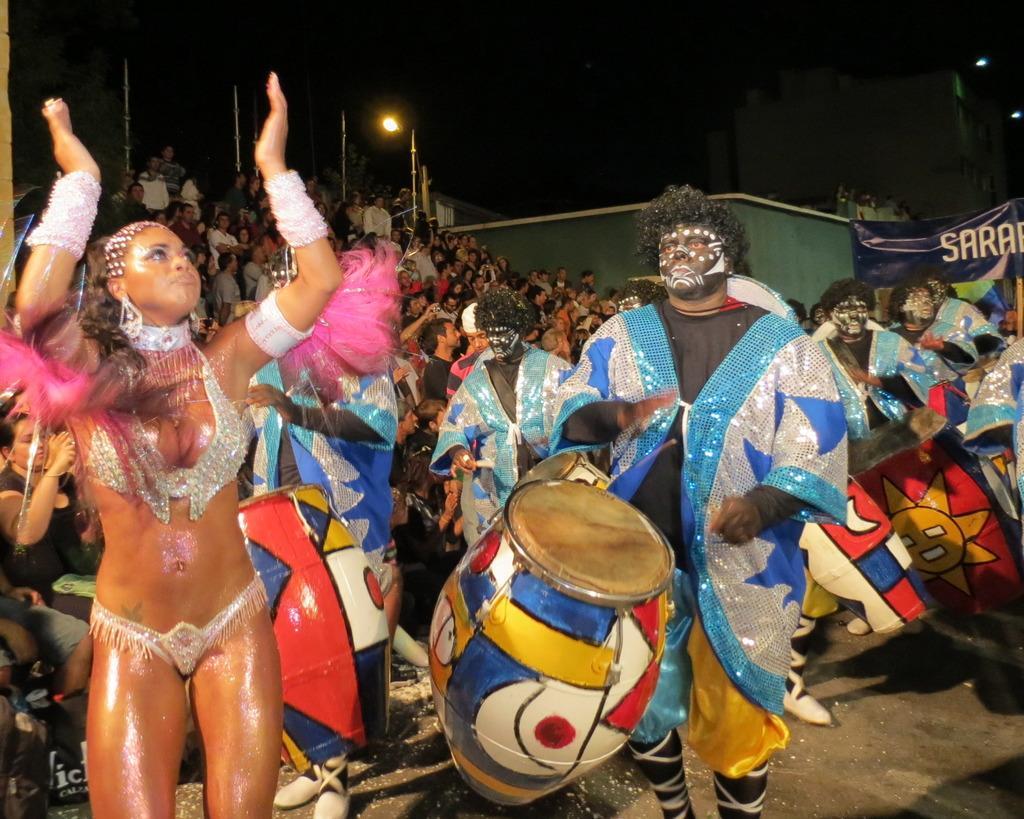In one or two sentences, can you explain what this image depicts? In this image I can see the group of people. Among them some people are playing the musical instrument. In the background there is a light,banner and the sky. 